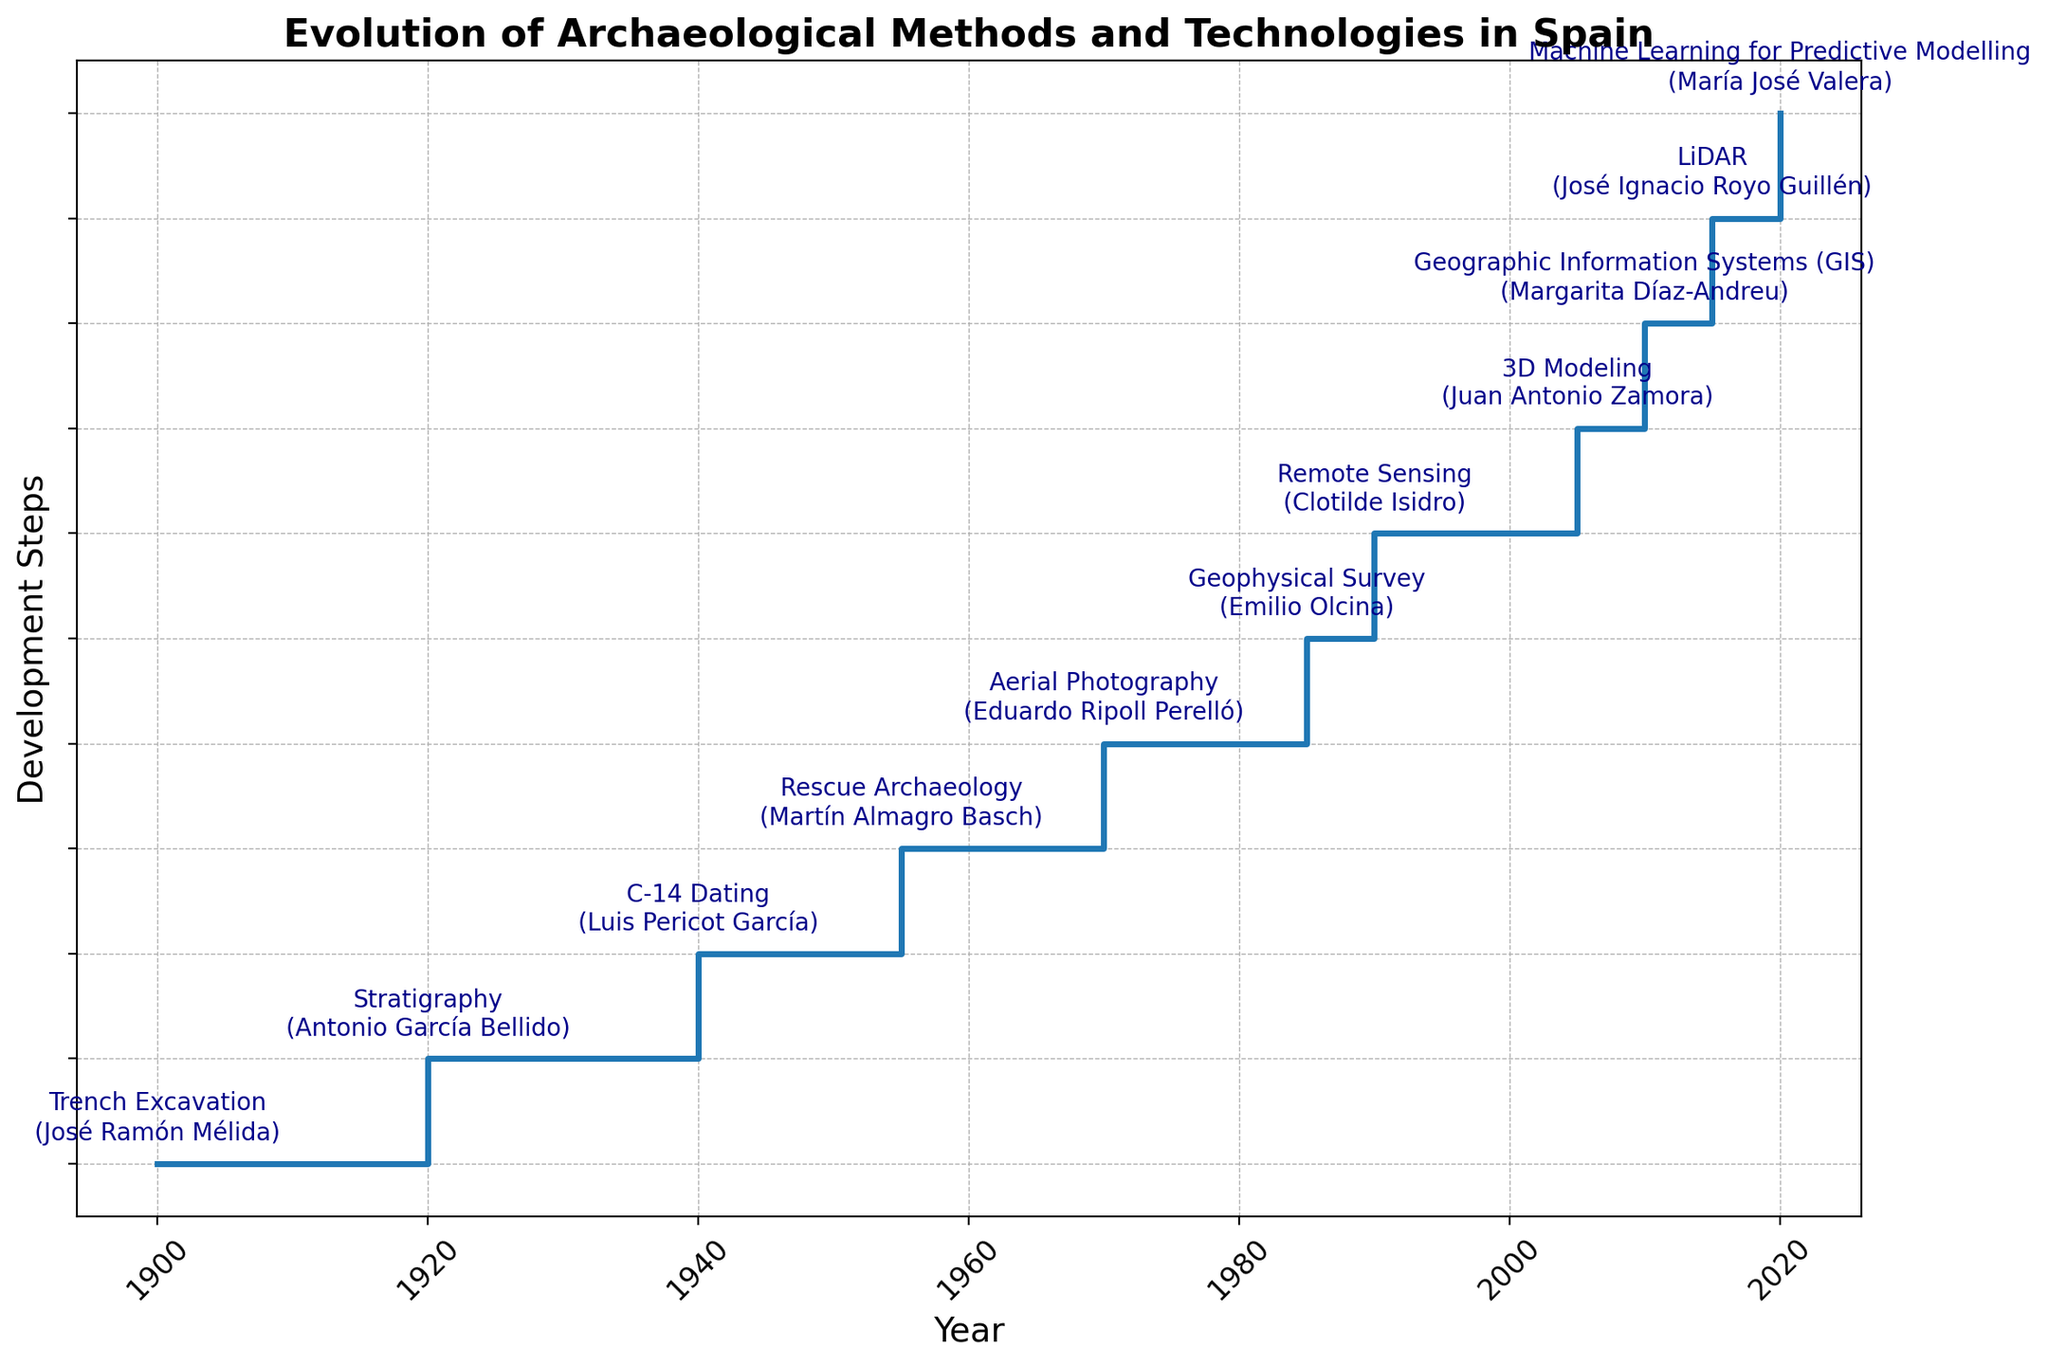What are the two most recent archaeological methods or technologies, and who were the key innovators? The two most recent methods or technologies are listed at the top of the stairs plot. They are "Machine Learning for Predictive Modelling" in 2020 by María José Valera and "LiDAR" in 2015 by José Ignacio Royo Guillén.
Answer: Machine Learning for Predictive Modelling by María José Valera and LiDAR by José Ignacio Royo Guillén Which method or technology was introduced in 1955 and by whom? Locate the point corresponding to the year 1955 on the horizontal axis and read the annotated text at that height in the plot. The method is "Rescue Archaeology" and the key innovator is Martín Almagro Basch.
Answer: Rescue Archaeology by Martín Almagro Basch How many years after the introduction of C-14 Dating was Geographic Information Systems (GIS) introduced? First, find the years when C-14 Dating and GIS were introduced, which are 1940 and 2010 respectively. Calculate the difference between these years: 2010 - 1940 = 70 years.
Answer: 70 years Who introduced Geophysical Survey and in which year? Identify the method "Geophysical Survey" in the annotations on the plot and read the corresponding year on the horizontal axis, which is 1985. The key innovator is Emilio Olcina.
Answer: Emilio Olcina in 1985 Which method or technology was introduced soon after Aerial Photography and who was the key innovator? Find "Aerial Photography" on the plot and identify the next step in the stairs. Aerial Photography was introduced in 1970. The next step is "Geophysical Survey" introduced in 1985 by Emilio Olcina.
Answer: Geophysical Survey by Emilio Olcina Compute the average time interval between the introduction of successive methods from 1900 to 2020. Calculate the differences between successive years: 1920-1900, 1940-1920, 1955-1940, etc. Sum these differences and divide by the number of intervals.
(1920-1900) + (1940-1920) + (1955-1940) + (1970-1955) + (1985-1970) + (1990-1985) + (2005-1990) + (2010-2005) + (2015-2010) + (2020-2015) = 20 + 20 + 15 + 15 + 15 + 5 + 15 + 5 + 5 + 5 = 120 years
Number of intervals = 10
Average = 120/10 = 12 years
Answer: 12 years What is the difference in years between the introduction of Stratigraphy and Remote Sensing? Find the years when Stratigraphy and Remote Sensing were introduced, which are 1920 and 1990 respectively. Calculate the difference: 1990 - 1920 = 70 years.
Answer: 70 years 